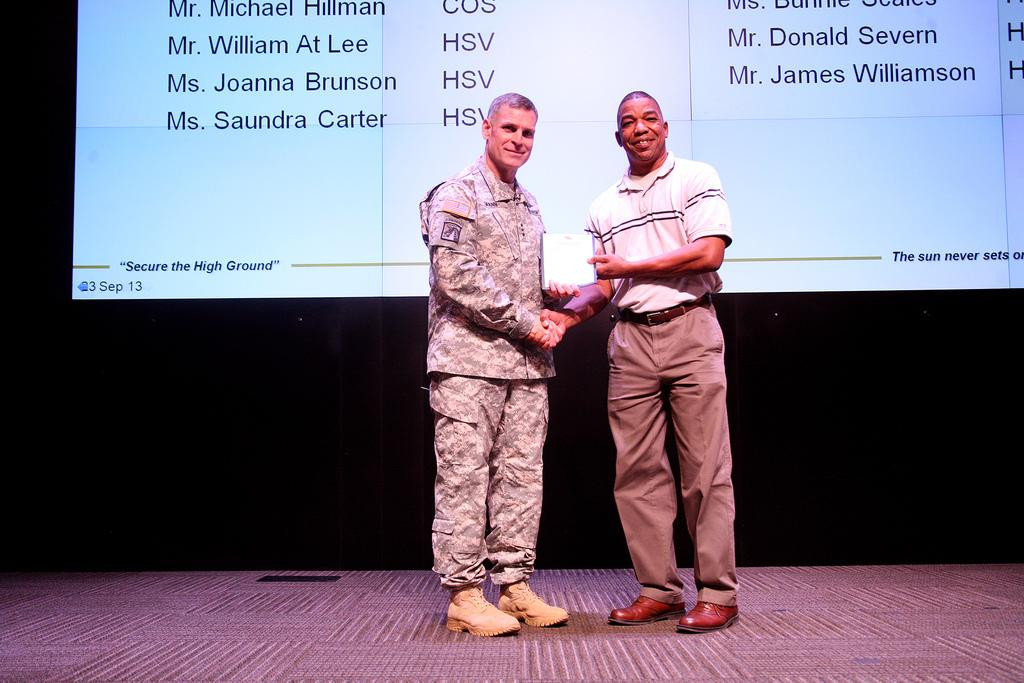How many people are in the image? There are two persons in the image. What are the two persons doing in the image? The two persons are shaking and hanging in the image. Where are the two persons located? The two persons are standing on a stage in the image. What is present behind the two persons? There is a screen behind the two persons in the image. What type of cakes are being offered for selection on the stage? There are no cakes present in the image; the two persons are shaking and hanging on a stage with a screen behind them. 